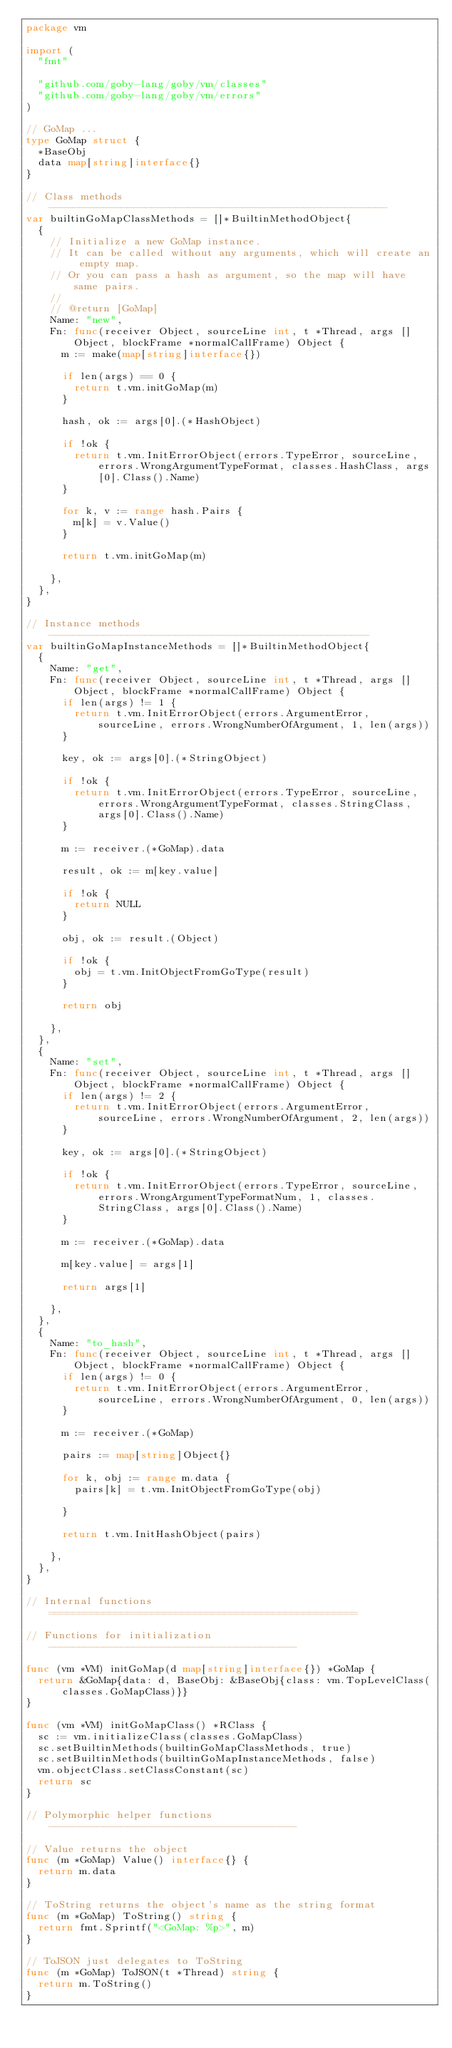Convert code to text. <code><loc_0><loc_0><loc_500><loc_500><_Go_>package vm

import (
	"fmt"

	"github.com/goby-lang/goby/vm/classes"
	"github.com/goby-lang/goby/vm/errors"
)

// GoMap ...
type GoMap struct {
	*BaseObj
	data map[string]interface{}
}

// Class methods --------------------------------------------------------
var builtinGoMapClassMethods = []*BuiltinMethodObject{
	{
		// Initialize a new GoMap instance.
		// It can be called without any arguments, which will create an empty map.
		// Or you can pass a hash as argument, so the map will have same pairs.
		//
		// @return [GoMap]
		Name: "new",
		Fn: func(receiver Object, sourceLine int, t *Thread, args []Object, blockFrame *normalCallFrame) Object {
			m := make(map[string]interface{})

			if len(args) == 0 {
				return t.vm.initGoMap(m)
			}

			hash, ok := args[0].(*HashObject)

			if !ok {
				return t.vm.InitErrorObject(errors.TypeError, sourceLine, errors.WrongArgumentTypeFormat, classes.HashClass, args[0].Class().Name)
			}

			for k, v := range hash.Pairs {
				m[k] = v.Value()
			}

			return t.vm.initGoMap(m)

		},
	},
}

// Instance methods -----------------------------------------------------
var builtinGoMapInstanceMethods = []*BuiltinMethodObject{
	{
		Name: "get",
		Fn: func(receiver Object, sourceLine int, t *Thread, args []Object, blockFrame *normalCallFrame) Object {
			if len(args) != 1 {
				return t.vm.InitErrorObject(errors.ArgumentError, sourceLine, errors.WrongNumberOfArgument, 1, len(args))
			}

			key, ok := args[0].(*StringObject)

			if !ok {
				return t.vm.InitErrorObject(errors.TypeError, sourceLine, errors.WrongArgumentTypeFormat, classes.StringClass, args[0].Class().Name)
			}

			m := receiver.(*GoMap).data

			result, ok := m[key.value]

			if !ok {
				return NULL
			}

			obj, ok := result.(Object)

			if !ok {
				obj = t.vm.InitObjectFromGoType(result)
			}

			return obj

		},
	},
	{
		Name: "set",
		Fn: func(receiver Object, sourceLine int, t *Thread, args []Object, blockFrame *normalCallFrame) Object {
			if len(args) != 2 {
				return t.vm.InitErrorObject(errors.ArgumentError, sourceLine, errors.WrongNumberOfArgument, 2, len(args))
			}

			key, ok := args[0].(*StringObject)

			if !ok {
				return t.vm.InitErrorObject(errors.TypeError, sourceLine, errors.WrongArgumentTypeFormatNum, 1, classes.StringClass, args[0].Class().Name)
			}

			m := receiver.(*GoMap).data

			m[key.value] = args[1]

			return args[1]

		},
	},
	{
		Name: "to_hash",
		Fn: func(receiver Object, sourceLine int, t *Thread, args []Object, blockFrame *normalCallFrame) Object {
			if len(args) != 0 {
				return t.vm.InitErrorObject(errors.ArgumentError, sourceLine, errors.WrongNumberOfArgument, 0, len(args))
			}

			m := receiver.(*GoMap)

			pairs := map[string]Object{}

			for k, obj := range m.data {
				pairs[k] = t.vm.InitObjectFromGoType(obj)

			}

			return t.vm.InitHashObject(pairs)

		},
	},
}

// Internal functions ===================================================

// Functions for initialization -----------------------------------------

func (vm *VM) initGoMap(d map[string]interface{}) *GoMap {
	return &GoMap{data: d, BaseObj: &BaseObj{class: vm.TopLevelClass(classes.GoMapClass)}}
}

func (vm *VM) initGoMapClass() *RClass {
	sc := vm.initializeClass(classes.GoMapClass)
	sc.setBuiltinMethods(builtinGoMapClassMethods, true)
	sc.setBuiltinMethods(builtinGoMapInstanceMethods, false)
	vm.objectClass.setClassConstant(sc)
	return sc
}

// Polymorphic helper functions -----------------------------------------

// Value returns the object
func (m *GoMap) Value() interface{} {
	return m.data
}

// ToString returns the object's name as the string format
func (m *GoMap) ToString() string {
	return fmt.Sprintf("<GoMap: %p>", m)
}

// ToJSON just delegates to ToString
func (m *GoMap) ToJSON(t *Thread) string {
	return m.ToString()
}
</code> 